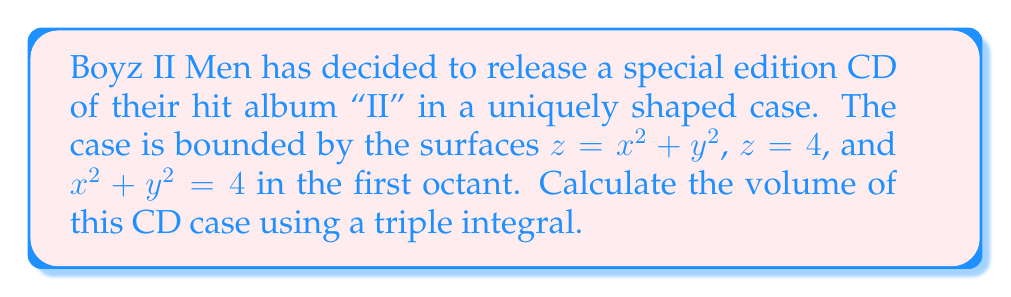Show me your answer to this math problem. To solve this problem, we'll use cylindrical coordinates and set up a triple integral. Let's approach this step-by-step:

1) First, let's visualize the shape. It's a portion of a paraboloid $z = x^2 + y^2$ cut off by the plane $z = 4$ and the cylinder $x^2 + y^2 = 4$ in the first octant.

2) In cylindrical coordinates:
   $x = r \cos\theta$
   $y = r \sin\theta$
   $z = z$

3) The bounds for our integral will be:
   $0 \leq \theta \leq \frac{\pi}{2}$ (first quadrant in xy-plane)
   $0 \leq r \leq 2$ (from $x^2 + y^2 = 4$)
   $r^2 \leq z \leq 4$ (from $z = x^2 + y^2$ and $z = 4$)

4) The volume integral in cylindrical coordinates is:
   $$V = \int_0^{\frac{\pi}{2}} \int_0^2 \int_{r^2}^4 r \, dz \, dr \, d\theta$$

5) Let's solve the integral:
   $$V = \int_0^{\frac{\pi}{2}} \int_0^2 r(4 - r^2) \, dr \, d\theta$$
   $$= \int_0^{\frac{\pi}{2}} \left[2r^2 - \frac{r^4}{4}\right]_0^2 \, d\theta$$
   $$= \int_0^{\frac{\pi}{2}} (8 - 1) \, d\theta$$
   $$= 7 \int_0^{\frac{\pi}{2}} \, d\theta$$
   $$= 7 \cdot \frac{\pi}{2}$$
   $$= \frac{7\pi}{2}$$

Therefore, the volume of the CD case is $\frac{7\pi}{2}$ cubic units.
Answer: $\frac{7\pi}{2}$ cubic units 